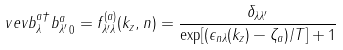<formula> <loc_0><loc_0><loc_500><loc_500>\ v e v { b _ { \lambda } ^ { a \dagger } b _ { \lambda ^ { \prime } } ^ { a } } _ { 0 } = f ^ { ( a ) } _ { \lambda ^ { \prime } \lambda } ( k _ { z } , n ) = \frac { \delta _ { \lambda \lambda ^ { \prime } } } { \exp [ ( \epsilon _ { n \lambda } ( k _ { z } ) - \zeta _ { a } ) / T ] + 1 }</formula> 